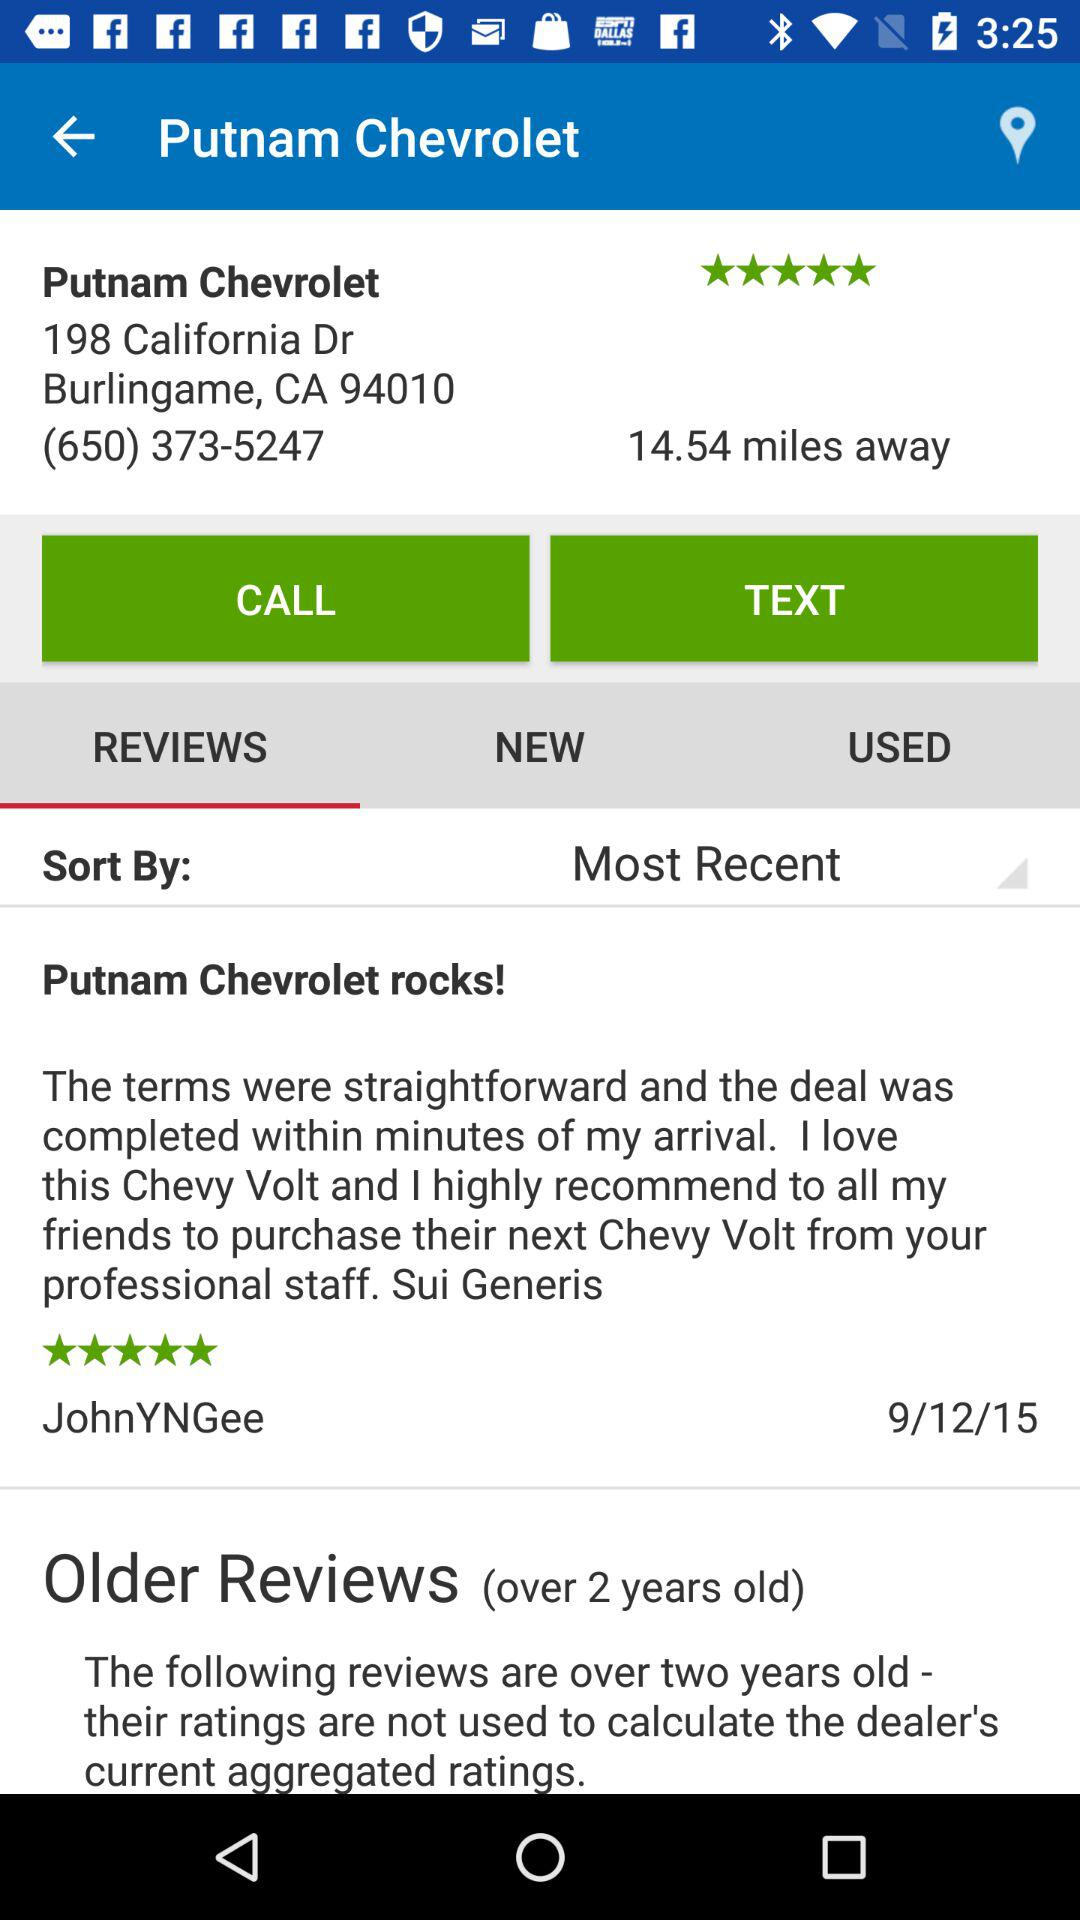What is the name of the dealer? The name is Putnam Chevrolet. 